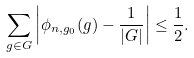Convert formula to latex. <formula><loc_0><loc_0><loc_500><loc_500>\sum _ { g \in G } \left | \phi _ { n , g _ { 0 } } ( g ) - \frac { 1 } { | G | } \right | \leq \frac { 1 } { 2 } .</formula> 